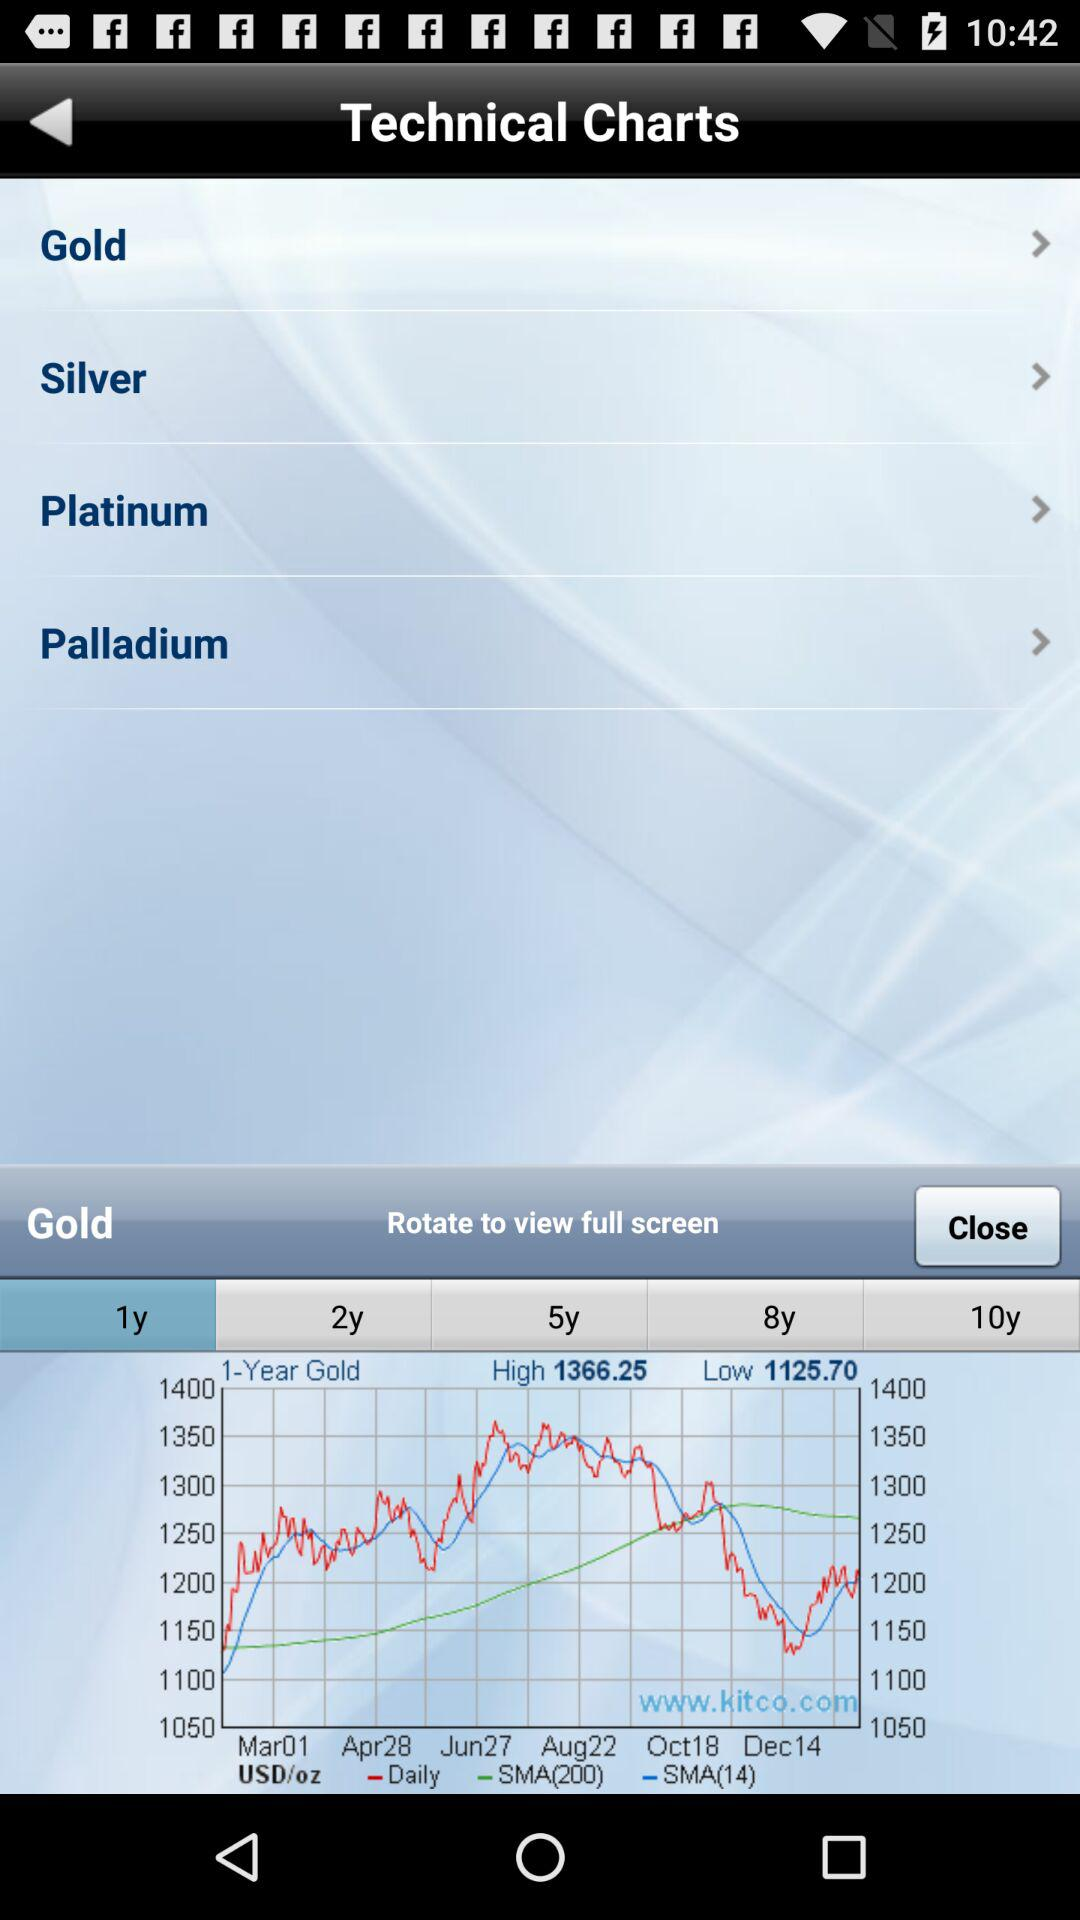The graph is given for which item? The graph is given for "Gold". 